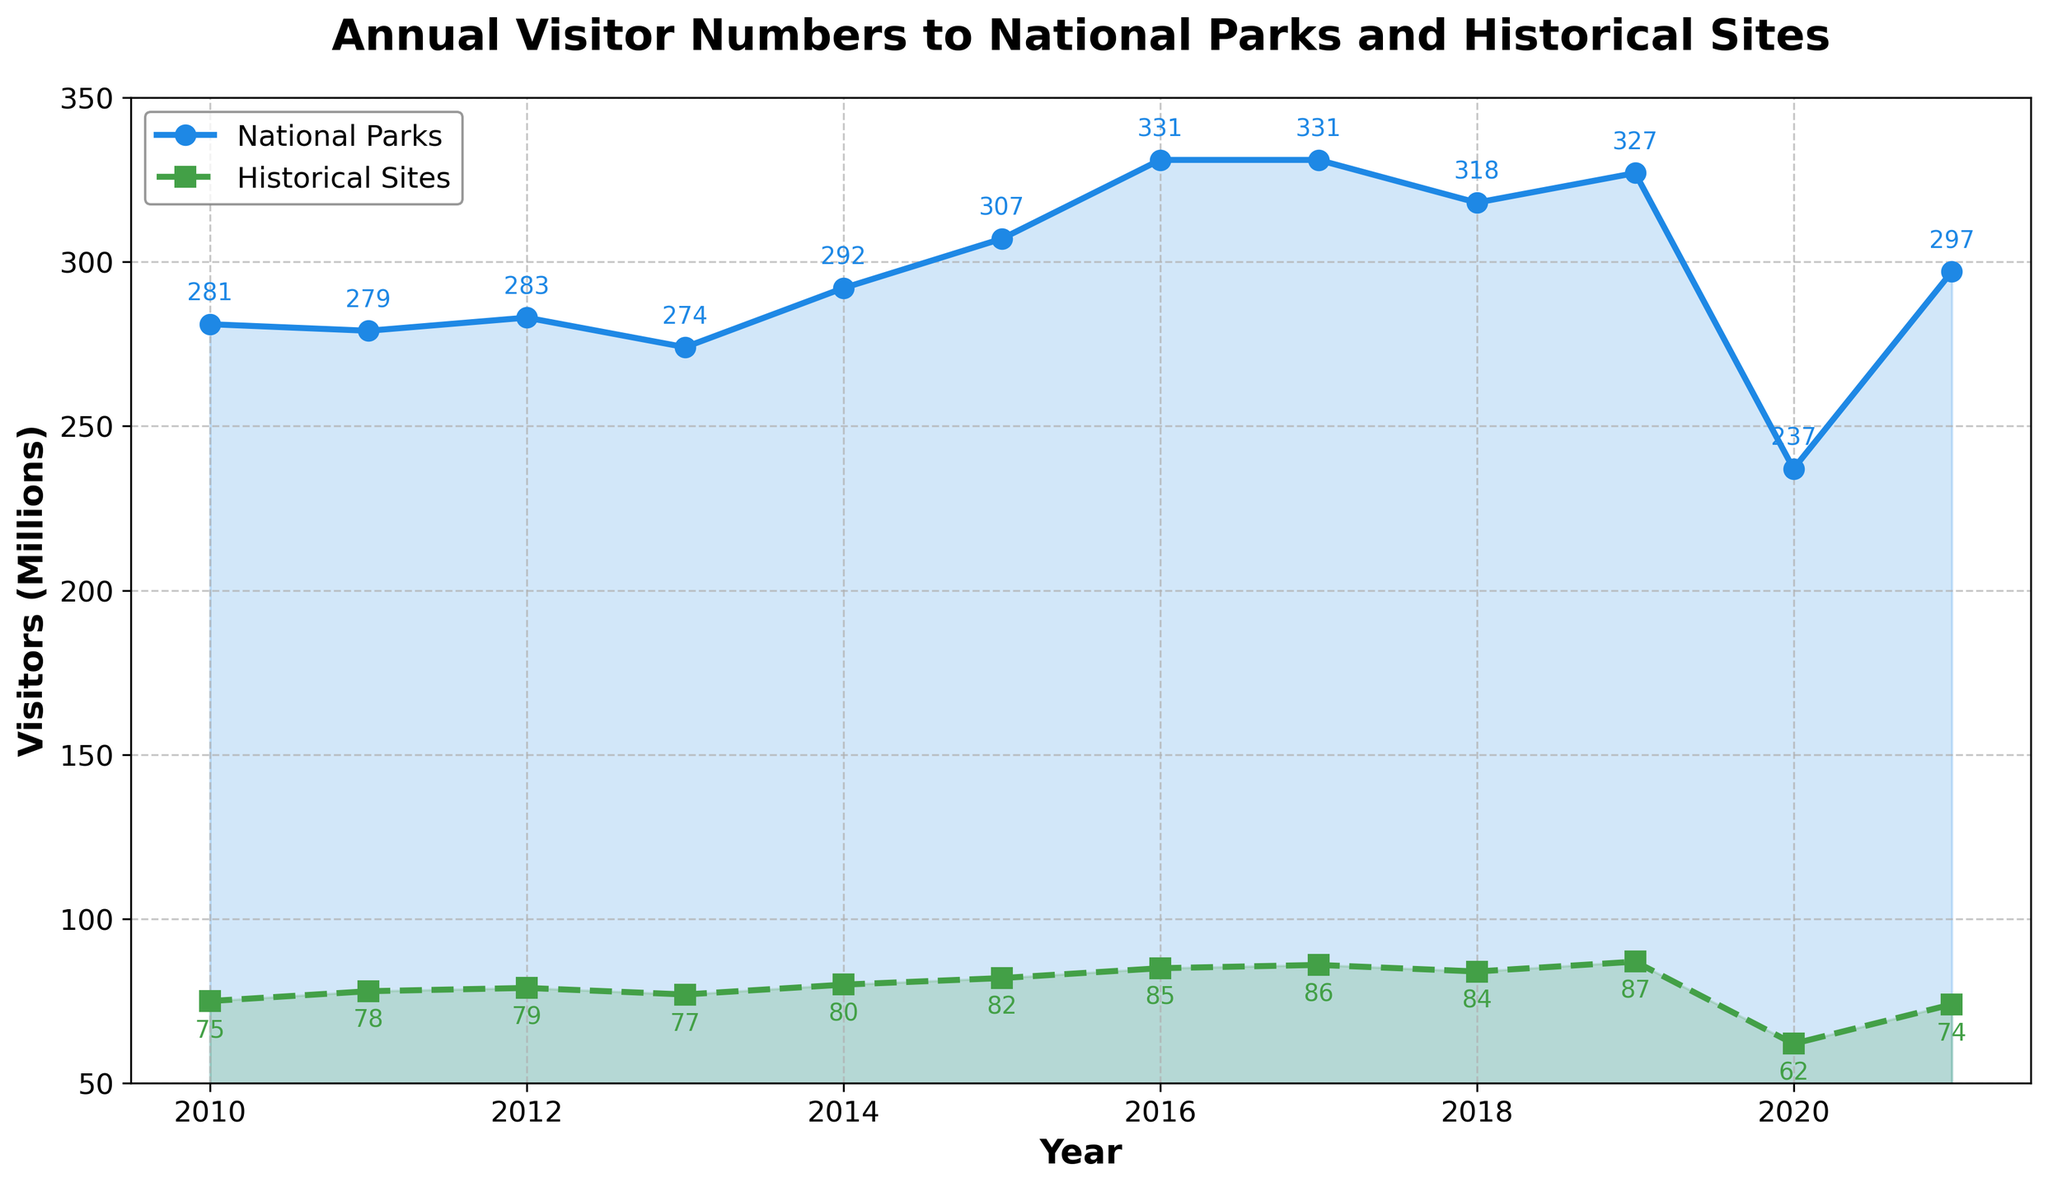What's the trend in visitor numbers to national parks from 2010 to 2021? The plot shows the visitor numbers to national parks from 2010 to 2021. Initially, the numbers fluctuated, rising significantly in 2014, peaking in 2016 and 2017, then declining in 2018. There was a sharp drop in 2020, presumably due to the pandemic, followed by a recovery in 2021.
Answer: Increasing, then decreasing, sharp drop in 2020, recovery in 2021 Which year had the highest number of visitors to historical sites? The line representing historical sites shows the highest visitor count at 87 million in 2019. This is identified by locating the peak point on the green dashed line.
Answer: 2019 How did the number of visitors to national parks change between 2019 and 2020? From the plot, the number of visitors to national parks dropped from approximately 327 million in 2019 to 237 million in 2020. This change is determined by looking at the values at these two points in time on the blue line.
Answer: Decreased by 90 million During which years did historical sites have more visitors compared to national parks? By comparing both lines, historical sites never had more visitors than national parks in any year from 2010 to 2021. The green dashed line is always below the blue solid line.
Answer: Never What's the average number of visitors to national parks from 2010 to 2021? To find the average, sum the visitor numbers for each year and divide by the total number of years. (281+279+283+274+292+307+331+331+318+327+237+297) million / 12 years = 2987 million / 12 = 248.92 million.
Answer: 248.92 million Which year saw the least number of visitors to historical sites? According to the plot, 2020 had the least number of visitors to historical sites with approximately 62 million. This is identified by the lowest point on the green dashed line.
Answer: 2020 What's the difference in visitor numbers to historical sites between the highest and lowest years? The highest visitor number was in 2019 (87 million), and the lowest was in 2020 (62 million). The difference is calculated as 87 million - 62 million = 25 million.
Answer: 25 million How did visitor numbers to historical sites in 2016 compare to those in 2014? From the plot, visitor numbers increased from approximately 80 million in 2014 to 85 million in 2016. This comparison is made by noting the positions of the green dashed line in these years.
Answer: Increased by 5 million 